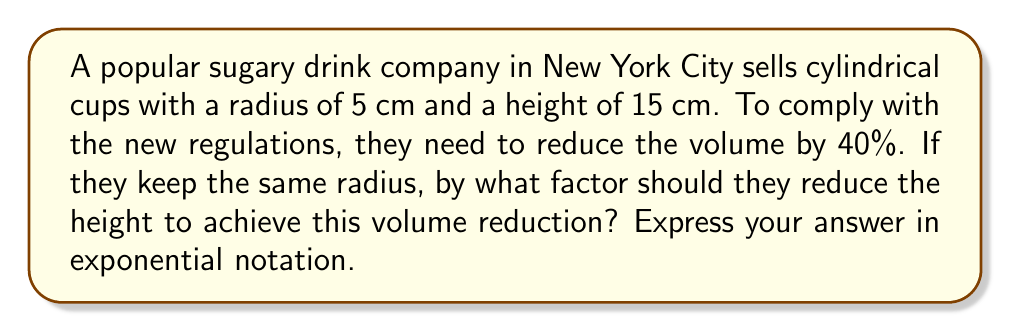Provide a solution to this math problem. Let's approach this step-by-step:

1) The volume of a cylinder is given by the formula:
   $V = \pi r^2 h$

2) We want to reduce this volume by 40%, which means the new volume will be 60% of the original. We can express this as:
   $V_{new} = 0.6V_{original}$

3) If we keep the radius constant and only change the height, we can write:
   $\pi r^2 h_{new} = 0.6(\pi r^2 h_{original})$

4) The $\pi r^2$ cancels out on both sides:
   $h_{new} = 0.6h_{original}$

5) This means the new height is 60% of the original height. To express this as a factor by which we're reducing the height, we need to find $x$ where:
   $h_{new} = xh_{original}$
   $0.6 = x$

6) To express 0.6 in exponential notation, we can write it as:
   $0.6 = 6 \times 10^{-1}$

Therefore, the height should be reduced by a factor of $6 \times 10^{-1}$.
Answer: $6 \times 10^{-1}$ 